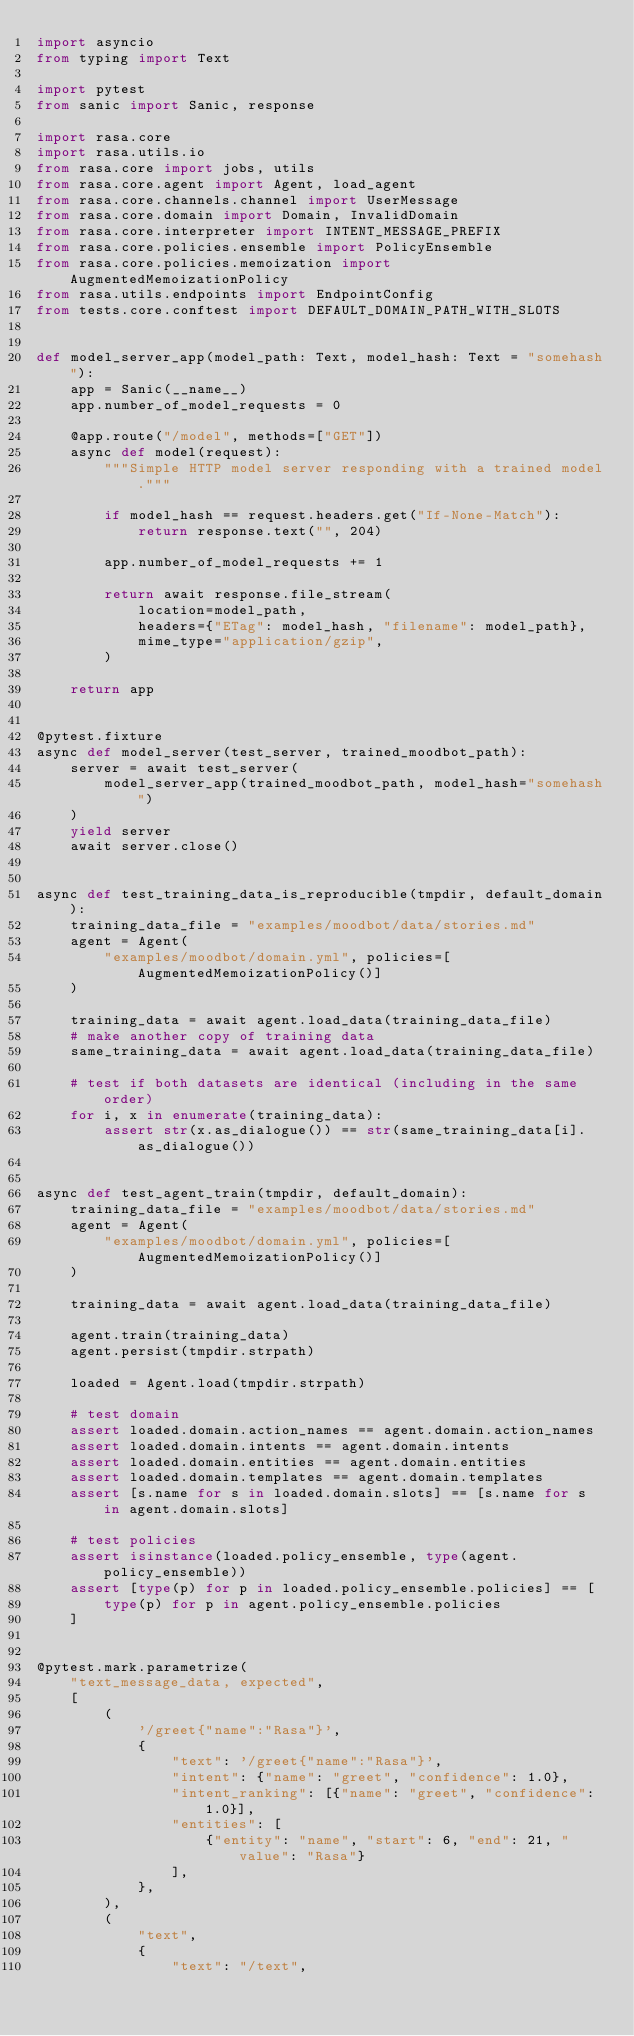Convert code to text. <code><loc_0><loc_0><loc_500><loc_500><_Python_>import asyncio
from typing import Text

import pytest
from sanic import Sanic, response

import rasa.core
import rasa.utils.io
from rasa.core import jobs, utils
from rasa.core.agent import Agent, load_agent
from rasa.core.channels.channel import UserMessage
from rasa.core.domain import Domain, InvalidDomain
from rasa.core.interpreter import INTENT_MESSAGE_PREFIX
from rasa.core.policies.ensemble import PolicyEnsemble
from rasa.core.policies.memoization import AugmentedMemoizationPolicy
from rasa.utils.endpoints import EndpointConfig
from tests.core.conftest import DEFAULT_DOMAIN_PATH_WITH_SLOTS


def model_server_app(model_path: Text, model_hash: Text = "somehash"):
    app = Sanic(__name__)
    app.number_of_model_requests = 0

    @app.route("/model", methods=["GET"])
    async def model(request):
        """Simple HTTP model server responding with a trained model."""

        if model_hash == request.headers.get("If-None-Match"):
            return response.text("", 204)

        app.number_of_model_requests += 1

        return await response.file_stream(
            location=model_path,
            headers={"ETag": model_hash, "filename": model_path},
            mime_type="application/gzip",
        )

    return app


@pytest.fixture
async def model_server(test_server, trained_moodbot_path):
    server = await test_server(
        model_server_app(trained_moodbot_path, model_hash="somehash")
    )
    yield server
    await server.close()


async def test_training_data_is_reproducible(tmpdir, default_domain):
    training_data_file = "examples/moodbot/data/stories.md"
    agent = Agent(
        "examples/moodbot/domain.yml", policies=[AugmentedMemoizationPolicy()]
    )

    training_data = await agent.load_data(training_data_file)
    # make another copy of training data
    same_training_data = await agent.load_data(training_data_file)

    # test if both datasets are identical (including in the same order)
    for i, x in enumerate(training_data):
        assert str(x.as_dialogue()) == str(same_training_data[i].as_dialogue())


async def test_agent_train(tmpdir, default_domain):
    training_data_file = "examples/moodbot/data/stories.md"
    agent = Agent(
        "examples/moodbot/domain.yml", policies=[AugmentedMemoizationPolicy()]
    )

    training_data = await agent.load_data(training_data_file)

    agent.train(training_data)
    agent.persist(tmpdir.strpath)

    loaded = Agent.load(tmpdir.strpath)

    # test domain
    assert loaded.domain.action_names == agent.domain.action_names
    assert loaded.domain.intents == agent.domain.intents
    assert loaded.domain.entities == agent.domain.entities
    assert loaded.domain.templates == agent.domain.templates
    assert [s.name for s in loaded.domain.slots] == [s.name for s in agent.domain.slots]

    # test policies
    assert isinstance(loaded.policy_ensemble, type(agent.policy_ensemble))
    assert [type(p) for p in loaded.policy_ensemble.policies] == [
        type(p) for p in agent.policy_ensemble.policies
    ]


@pytest.mark.parametrize(
    "text_message_data, expected",
    [
        (
            '/greet{"name":"Rasa"}',
            {
                "text": '/greet{"name":"Rasa"}',
                "intent": {"name": "greet", "confidence": 1.0},
                "intent_ranking": [{"name": "greet", "confidence": 1.0}],
                "entities": [
                    {"entity": "name", "start": 6, "end": 21, "value": "Rasa"}
                ],
            },
        ),
        (
            "text",
            {
                "text": "/text",</code> 